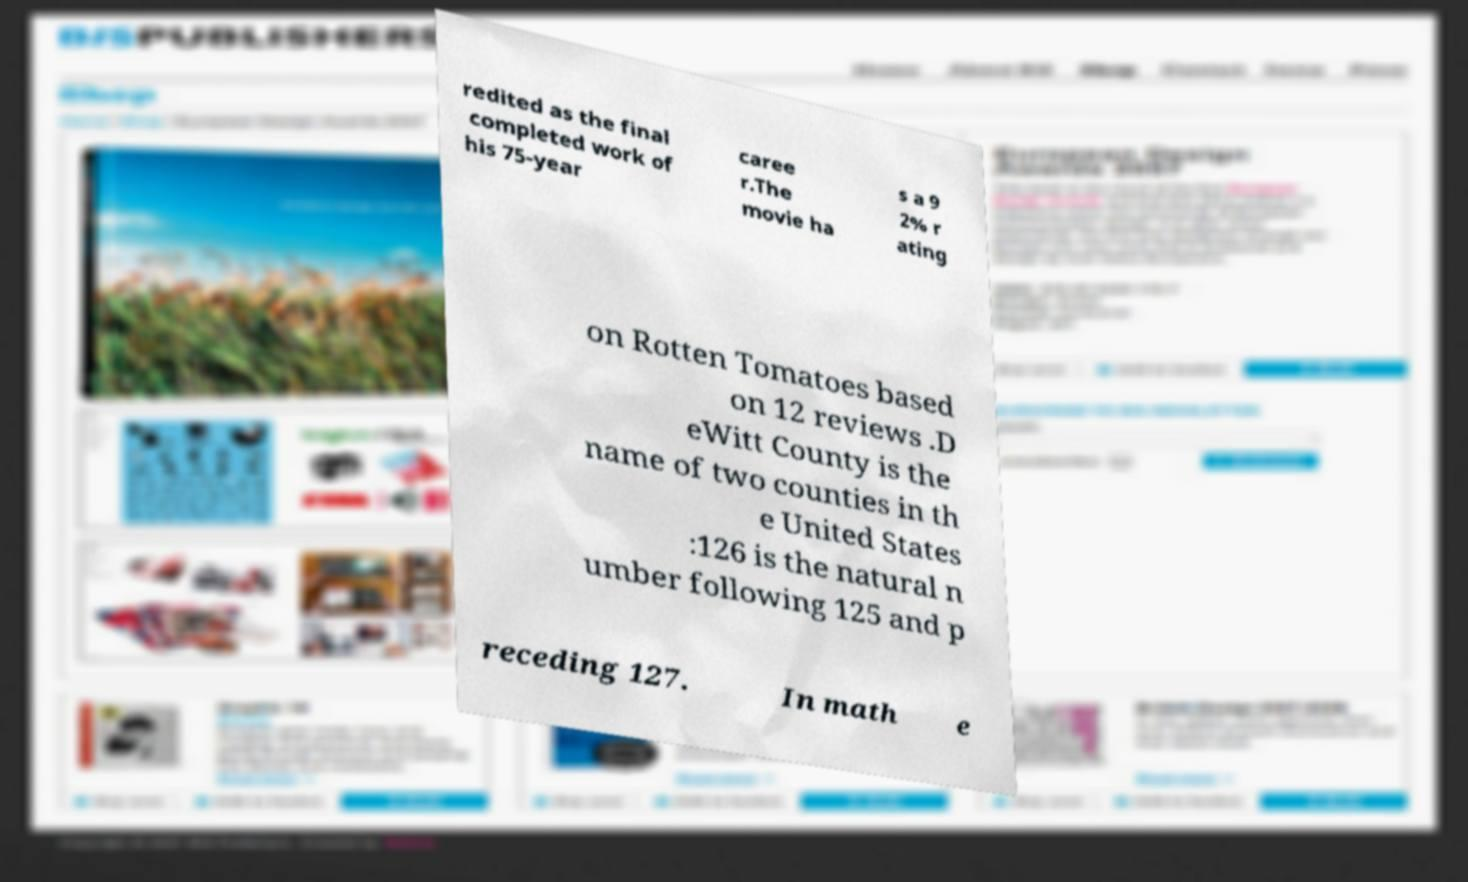There's text embedded in this image that I need extracted. Can you transcribe it verbatim? redited as the final completed work of his 75-year caree r.The movie ha s a 9 2% r ating on Rotten Tomatoes based on 12 reviews .D eWitt County is the name of two counties in th e United States :126 is the natural n umber following 125 and p receding 127. In math e 